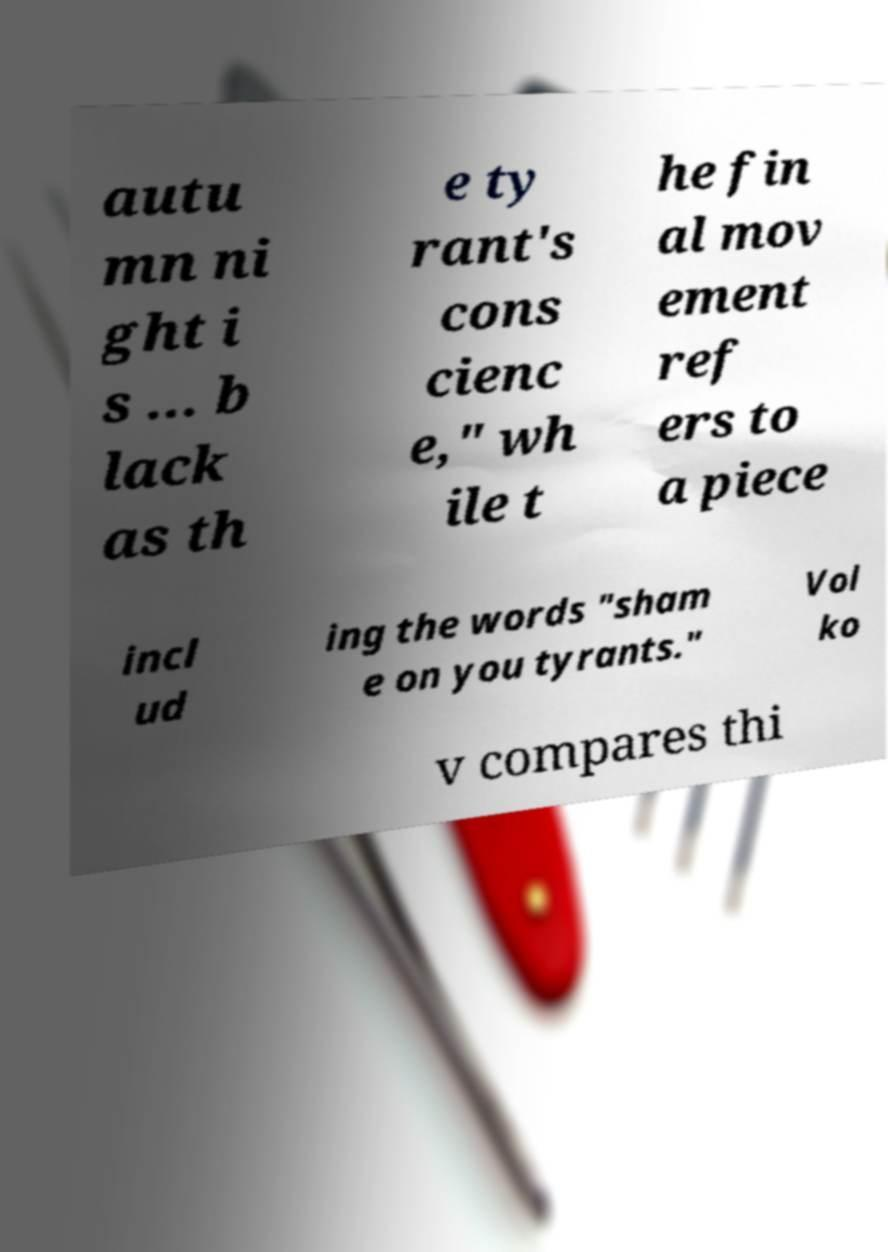Could you extract and type out the text from this image? autu mn ni ght i s ... b lack as th e ty rant's cons cienc e," wh ile t he fin al mov ement ref ers to a piece incl ud ing the words "sham e on you tyrants." Vol ko v compares thi 